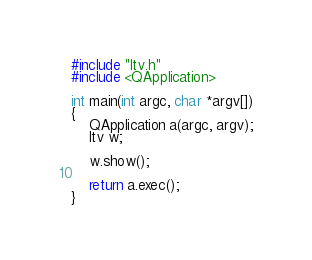<code> <loc_0><loc_0><loc_500><loc_500><_C++_>#include "ltv.h"
#include <QApplication>

int main(int argc, char *argv[])
{
    QApplication a(argc, argv);
    ltv w;

    w.show();

    return a.exec();
}
</code> 